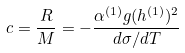<formula> <loc_0><loc_0><loc_500><loc_500>c = \frac { R } { M } = - \frac { \alpha ^ { ( 1 ) } g ( h ^ { ( 1 ) } ) ^ { 2 } } { d \sigma / d T }</formula> 